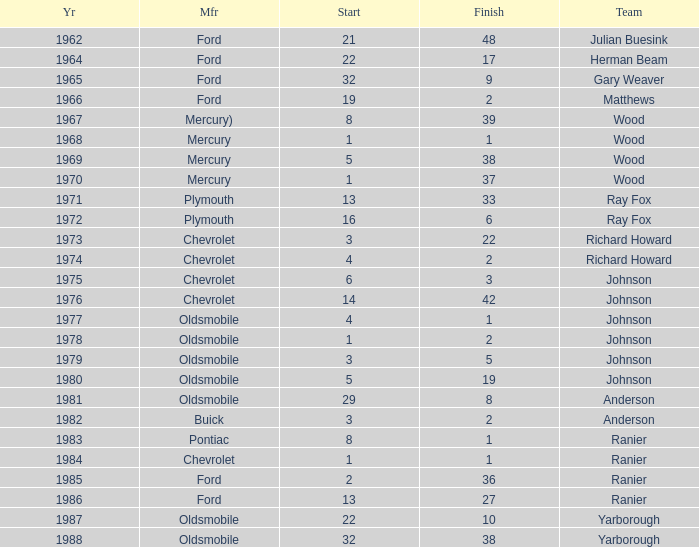Who was the maufacturer of the vehicle during the race where Cale Yarborough started at 19 and finished earlier than 42? Ford. 